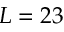Convert formula to latex. <formula><loc_0><loc_0><loc_500><loc_500>L = 2 3</formula> 